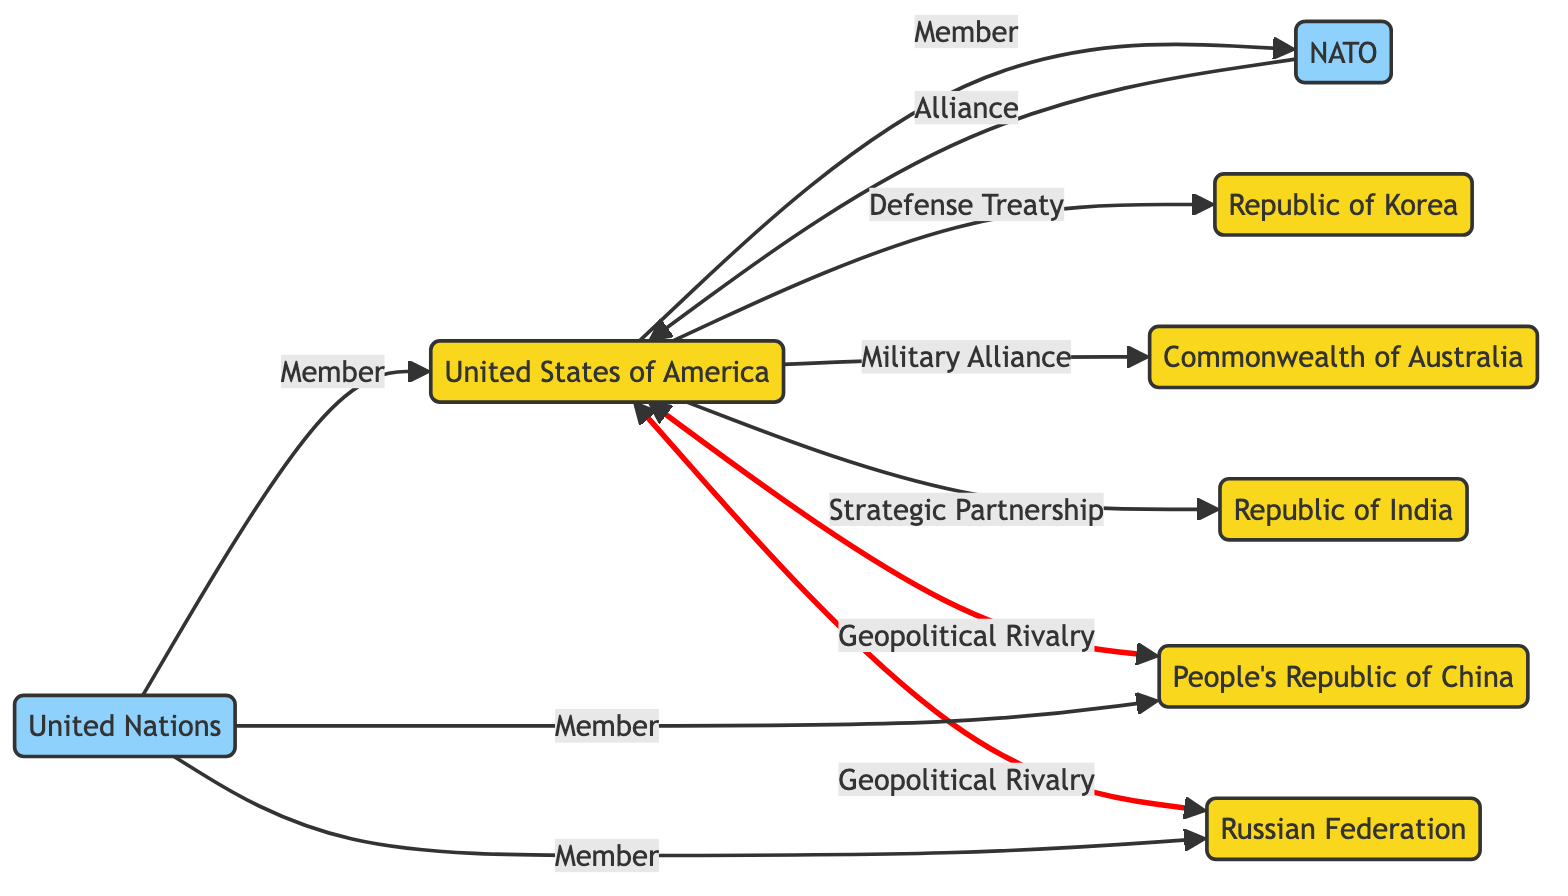What is the total number of countries represented in the diagram? The diagram includes eight nodes, which are the countries and organizations listed. Counting only the country nodes—USA, China, Russia, India, Australia, and South Korea—there are six countries. Therefore, the total number of countries is six.
Answer: 6 What relationship does the USA have with NATO? The relationship is indicated by an edge directed from the USA to NATO labeled "Member." This means the USA is a member of NATO.
Answer: Member Which country has a defense treaty with the USA? Looking at the edges, there is a direct edge from the USA to South Korea labeled "Defense Treaty," indicating this relationship.
Answer: South Korea How many organizations are represented in the graph? The graph features two organizations: NATO and the United Nations. Counting these, the total number of organizations is two.
Answer: 2 What two countries are in a geopolitical rivalry with the USA? The directed edges from the USA to China and Russia, both labeled "Geopolitical Rivalry," indicate these two countries are rivals of the USA. Thus, the answer includes both countries.
Answer: China, Russia What country is a strategic partner of the USA? The directed edge labeled "Strategic Partnership" leads from the USA to India, indicating that India is a strategic partner of the USA.
Answer: India Which organization does the USA belong to along with China and Russia? The United Nations is the organization that all three countries belong to, as indicated by the edges leading from UN to USA, China, and Russia, all labeled "Member."
Answer: United Nations How is the alliance between USA and NATO represented in the diagram? The alliance is illustrated by a directed edge from the USA to NATO with the label "Alliance," indicating the relationship.
Answer: Alliance How many geopolitical rivalries does the USA have? There are two directed edges directed away from the USA leading to China and Russia, both marked as "Geopolitical Rivalry." Therefore, the USA has two rivalries.
Answer: 2 